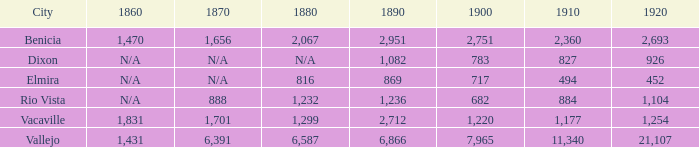What is the 1880 figure when 1860 is N/A and 1910 is 494? 816.0. 